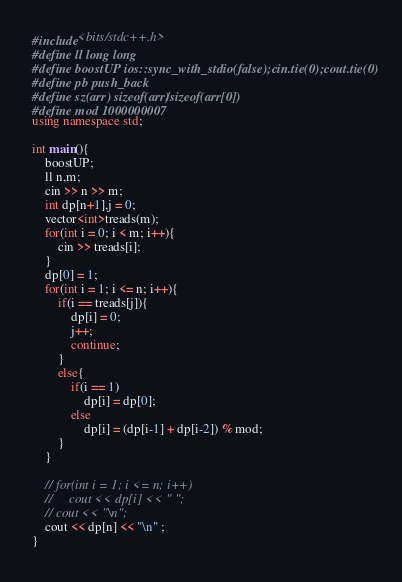Convert code to text. <code><loc_0><loc_0><loc_500><loc_500><_C++_>#include<bits/stdc++.h>
#define ll long long
#define boostUP ios::sync_with_stdio(false);cin.tie(0);cout.tie(0)
#define pb push_back
#define sz(arr) sizeof(arr)/sizeof(arr[0])
#define mod 1000000007
using namespace std;

int main(){
    boostUP;
    ll n,m;
    cin >> n >> m;
    int dp[n+1],j = 0;
    vector<int>treads(m);
    for(int i = 0; i < m; i++){
        cin >> treads[i];    
    }
    dp[0] = 1;
    for(int i = 1; i <= n; i++){
        if(i == treads[j]){
            dp[i] = 0;
            j++;
            continue;
        }
        else{
            if(i == 1)
                dp[i] = dp[0];
            else
                dp[i] = (dp[i-1] + dp[i-2]) % mod;
        }
    }

    // for(int i = 1; i <= n; i++)
    //     cout << dp[i] << " ";
    // cout << "\n";
    cout << dp[n] << "\n" ;
}


</code> 